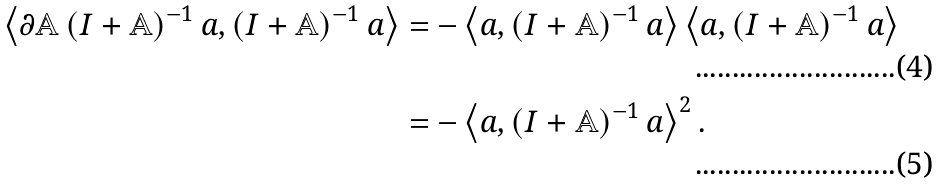<formula> <loc_0><loc_0><loc_500><loc_500>\left \langle \partial \mathbb { A } \left ( I + \mathbb { A } \right ) ^ { - 1 } a , \left ( I + \mathbb { A } \right ) ^ { - 1 } a \right \rangle & = - \left \langle a , \left ( I + \mathbb { A } \right ) ^ { - 1 } a \right \rangle \left \langle a , \left ( I + \mathbb { A } \right ) ^ { - 1 } a \right \rangle \\ & = - \left \langle a , \left ( I + \mathbb { A } \right ) ^ { - 1 } a \right \rangle ^ { 2 } .</formula> 